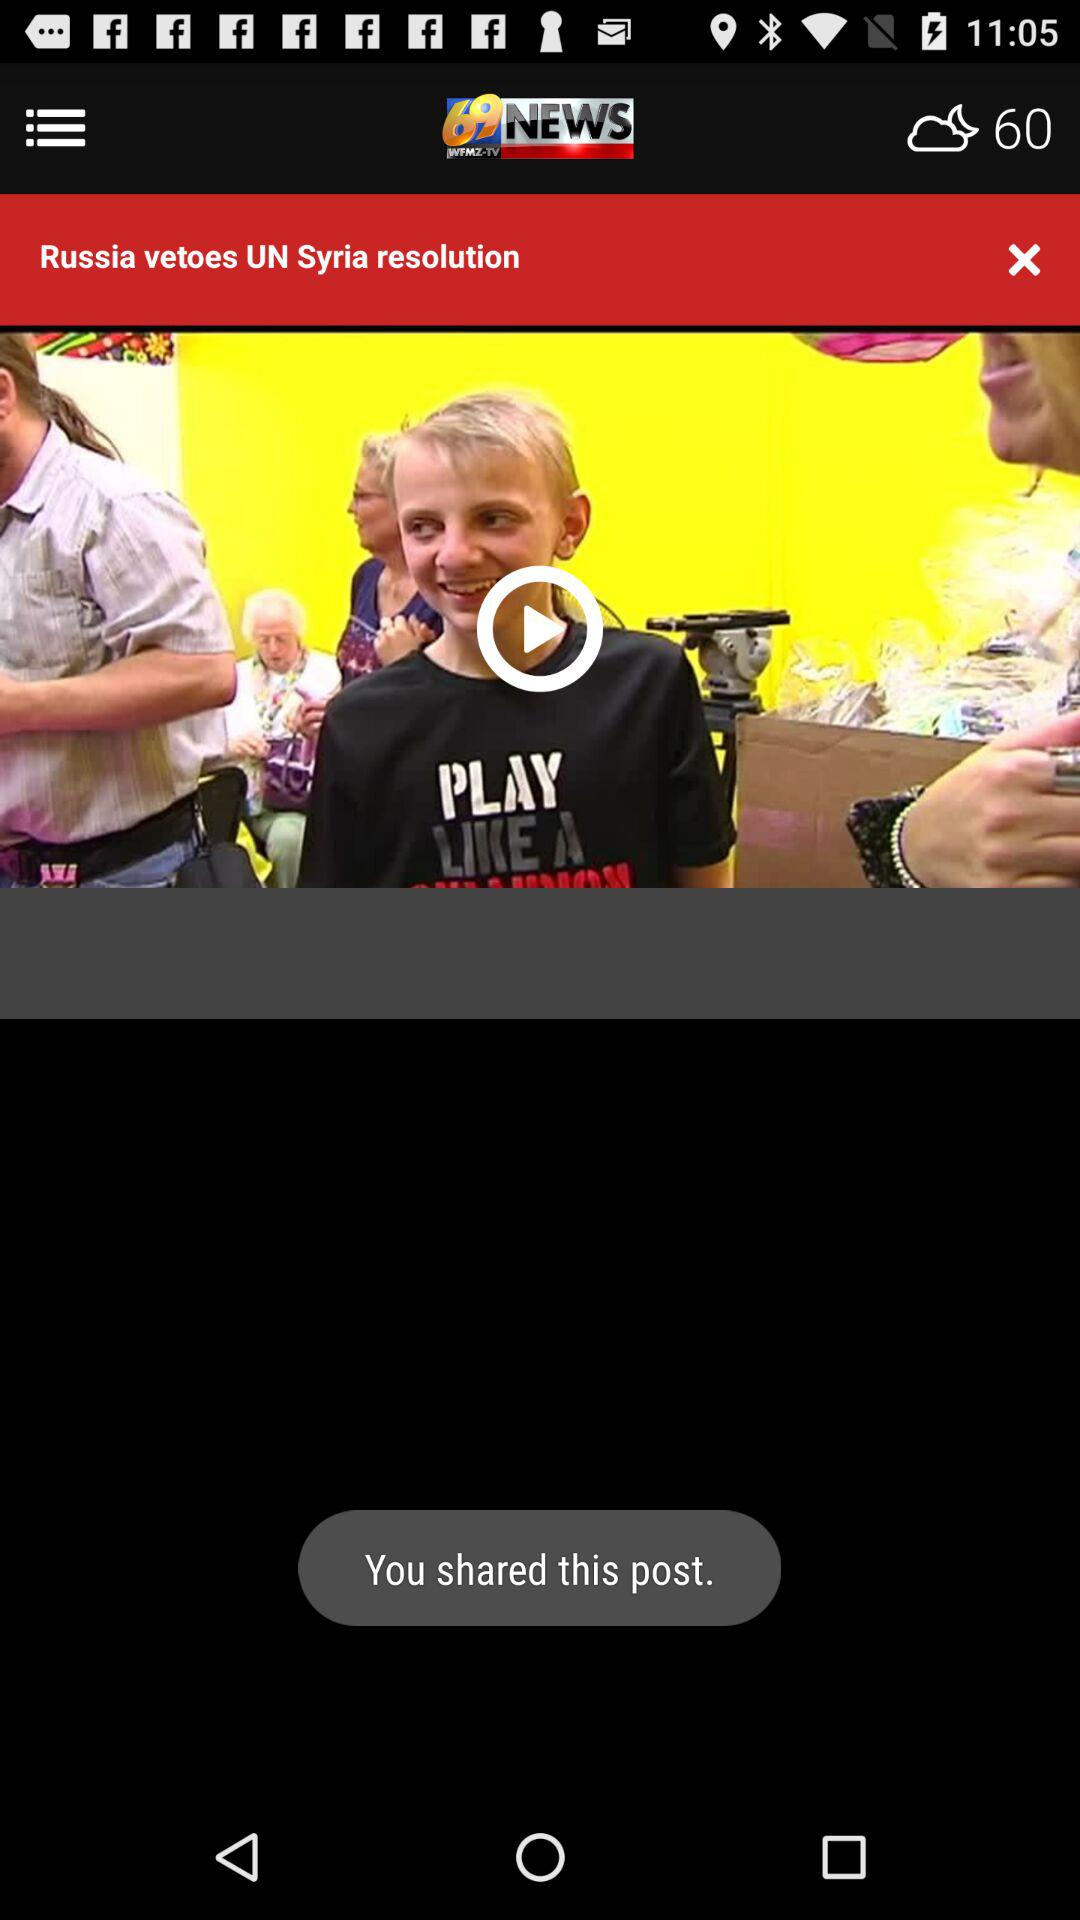What is the app name? The app name is "69News". 